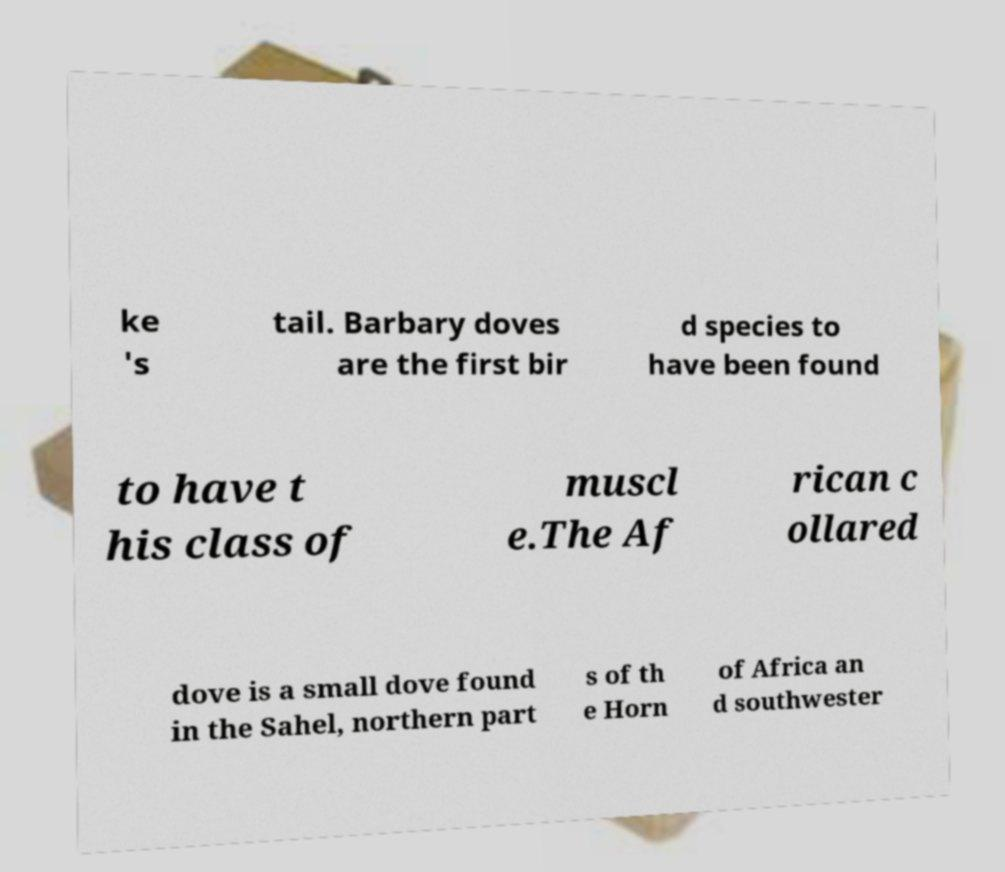Please identify and transcribe the text found in this image. ke 's tail. Barbary doves are the first bir d species to have been found to have t his class of muscl e.The Af rican c ollared dove is a small dove found in the Sahel, northern part s of th e Horn of Africa an d southwester 